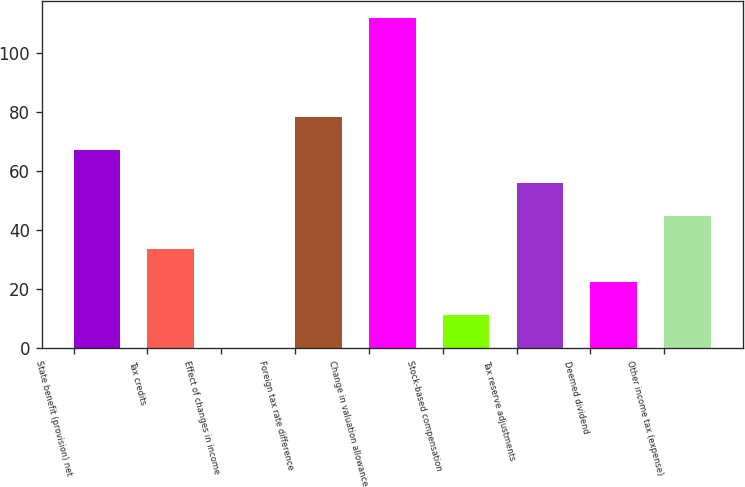<chart> <loc_0><loc_0><loc_500><loc_500><bar_chart><fcel>State benefit (provision) net<fcel>Tax credits<fcel>Effect of changes in income<fcel>Foreign tax rate difference<fcel>Change in valuation allowance<fcel>Stock-based compensation<fcel>Tax reserve adjustments<fcel>Deemed dividend<fcel>Other income tax (expense)<nl><fcel>67.22<fcel>33.62<fcel>0.02<fcel>78.42<fcel>112.02<fcel>11.22<fcel>56.02<fcel>22.42<fcel>44.82<nl></chart> 